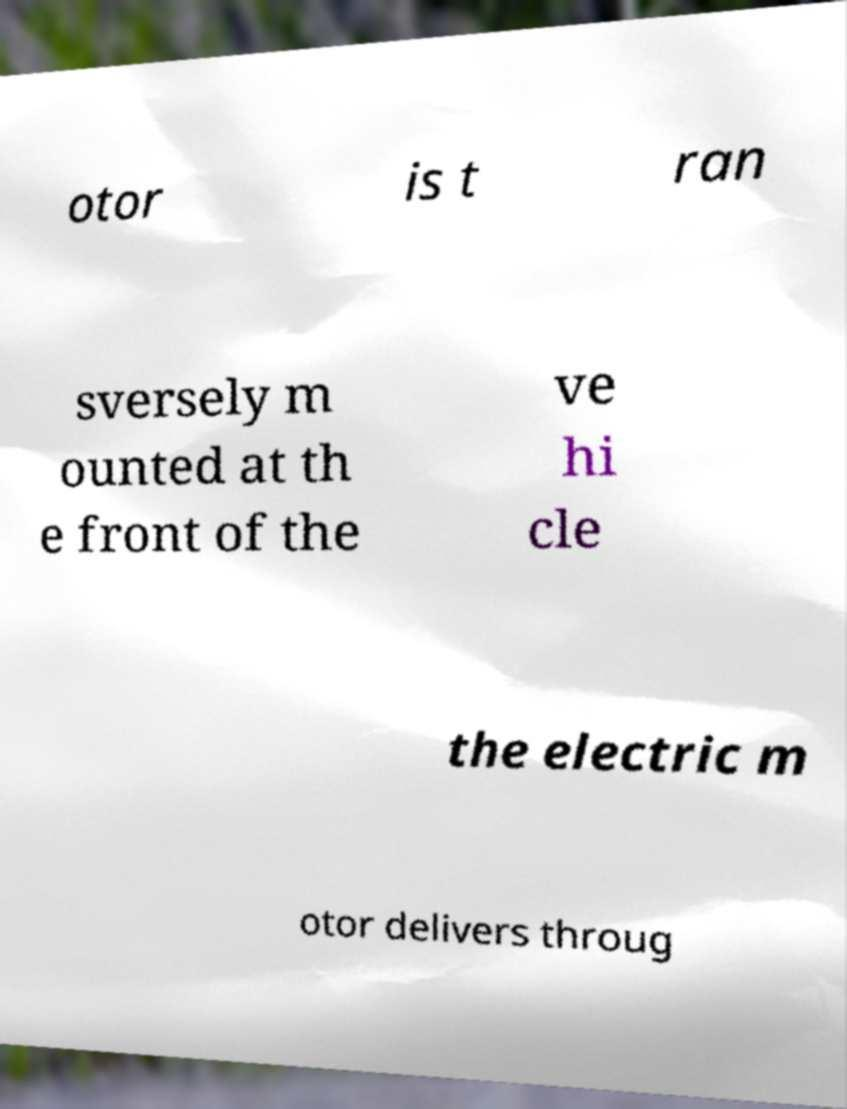I need the written content from this picture converted into text. Can you do that? otor is t ran sversely m ounted at th e front of the ve hi cle the electric m otor delivers throug 